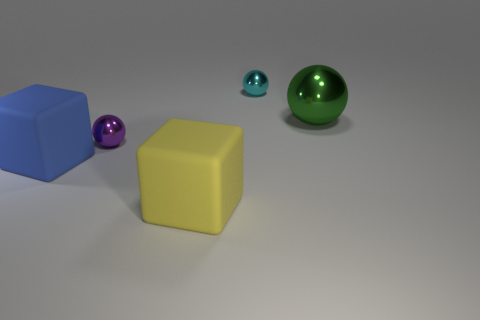What number of green things are either metallic blocks or metallic things?
Your response must be concise. 1. What number of other things are the same shape as the big yellow thing?
Your answer should be very brief. 1. There is a object that is to the right of the purple object and left of the cyan object; what shape is it?
Make the answer very short. Cube. Are there any shiny objects behind the large green thing?
Keep it short and to the point. Yes. There is a cyan shiny object that is the same shape as the large green object; what size is it?
Your answer should be compact. Small. Is the shape of the big yellow matte thing the same as the large blue thing?
Provide a succinct answer. Yes. How big is the cyan metal object that is behind the sphere that is to the left of the big yellow block?
Provide a succinct answer. Small. There is another large shiny thing that is the same shape as the purple object; what is its color?
Your answer should be compact. Green. How big is the cyan sphere?
Ensure brevity in your answer.  Small. Does the purple object have the same size as the blue matte object?
Your answer should be compact. No. 